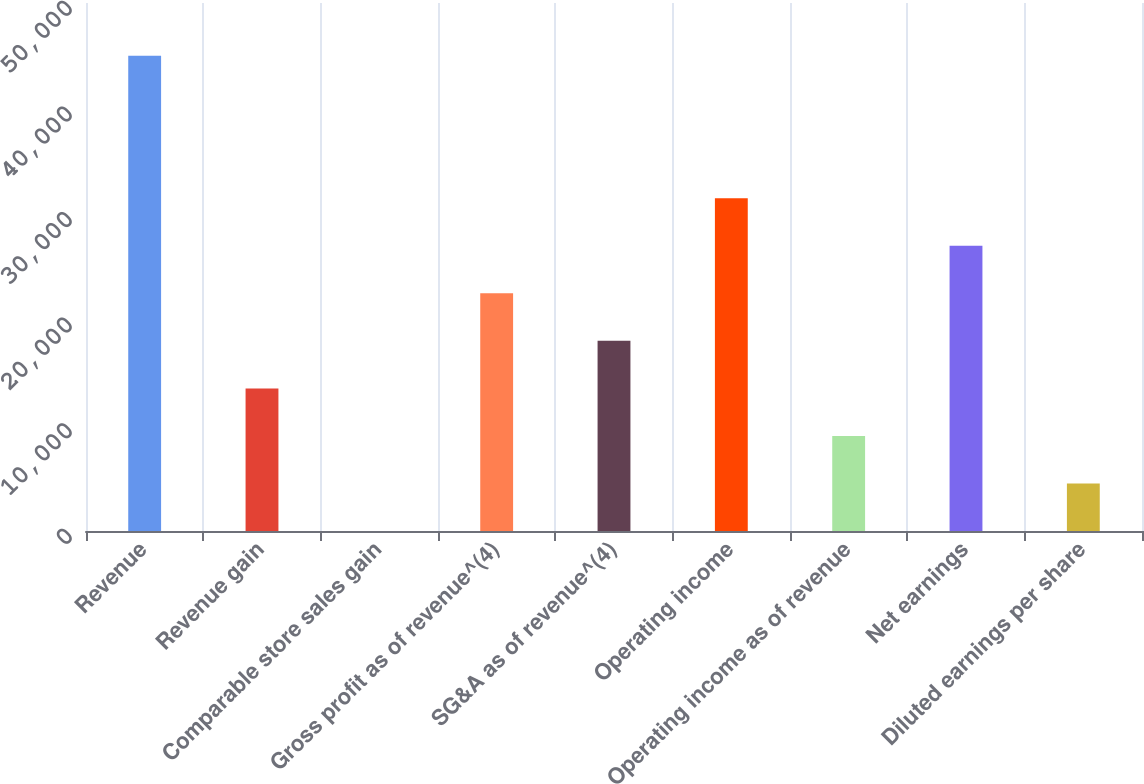<chart> <loc_0><loc_0><loc_500><loc_500><bar_chart><fcel>Revenue<fcel>Revenue gain<fcel>Comparable store sales gain<fcel>Gross profit as of revenue^(4)<fcel>SG&A as of revenue^(4)<fcel>Operating income<fcel>Operating income as of revenue<fcel>Net earnings<fcel>Diluted earnings per share<nl><fcel>45015<fcel>13505.4<fcel>1.3<fcel>22508.2<fcel>18006.8<fcel>31510.9<fcel>9004.04<fcel>27009.5<fcel>4502.67<nl></chart> 